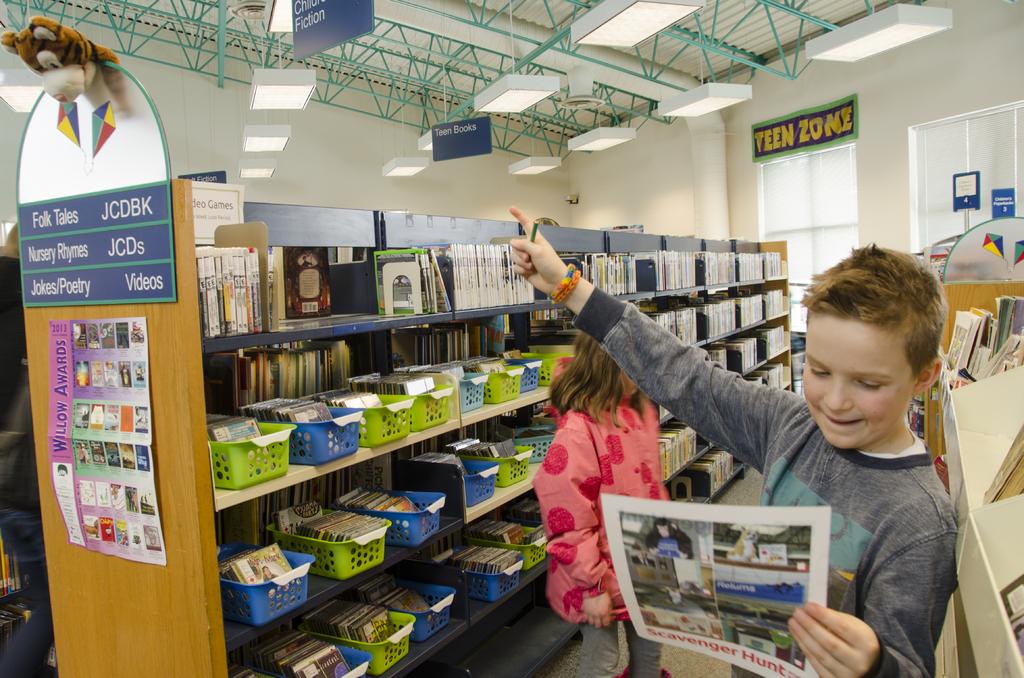What does the banner above the window say?
Your answer should be very brief. Teen zone. What is the zone?
Your answer should be very brief. Teen. 